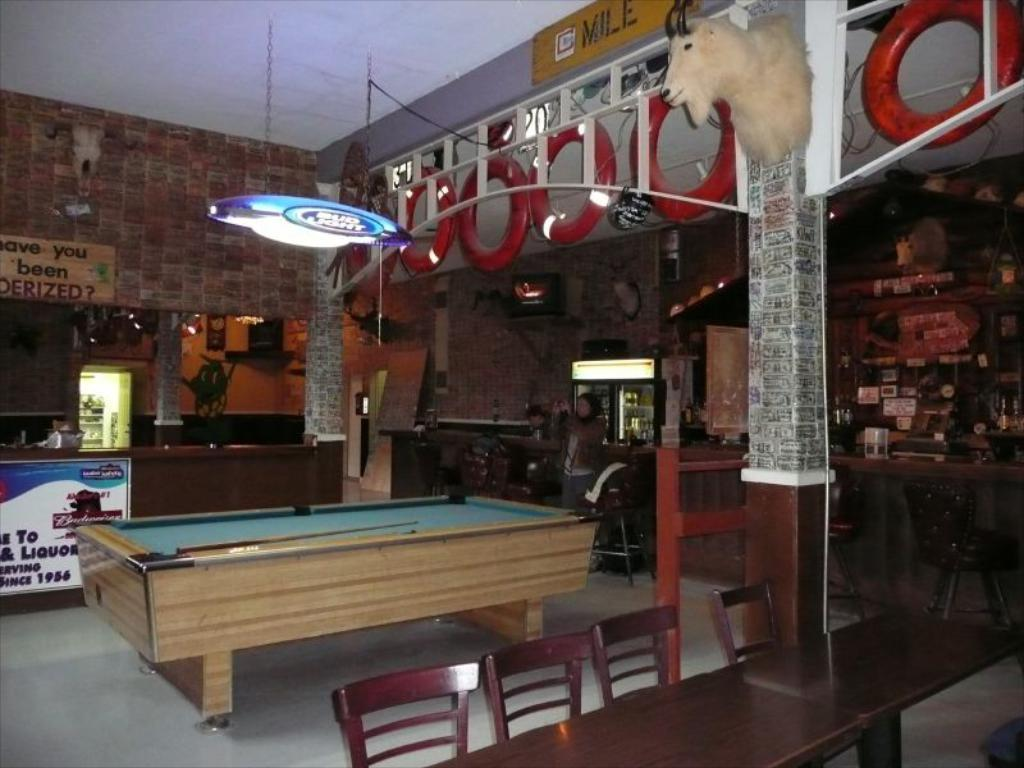What type of light is present in the image? There is a light in the image, but the specific type is not mentioned. What game is being played in the image? Snooker is being played, as evidenced by the presence of a snookers board and snooker sticks. What type of furniture is in the image? There is a chair and a table in the image. How many people are in the image? There are persons in the image, but the exact number is not specified. What appliance is visible in the image? There is a refrigerator in the image. Can you see any animals from the zoo in the image? There is no mention of a zoo or any animals in the image. Is there a volleyball game being played in the image? There is no indication of a volleyball game in the image; it features a snookers board and snooker sticks, suggesting a game of snooker is being played. 